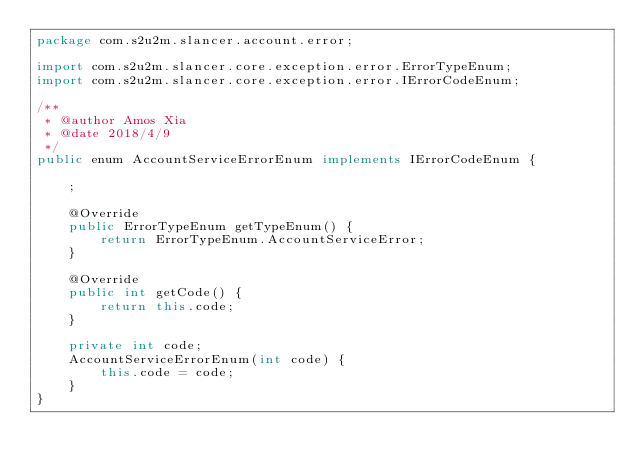Convert code to text. <code><loc_0><loc_0><loc_500><loc_500><_Java_>package com.s2u2m.slancer.account.error;

import com.s2u2m.slancer.core.exception.error.ErrorTypeEnum;
import com.s2u2m.slancer.core.exception.error.IErrorCodeEnum;

/**
 * @author Amos Xia
 * @date 2018/4/9
 */
public enum AccountServiceErrorEnum implements IErrorCodeEnum {

    ;

    @Override
    public ErrorTypeEnum getTypeEnum() {
        return ErrorTypeEnum.AccountServiceError;
    }

    @Override
    public int getCode() {
        return this.code;
    }

    private int code;
    AccountServiceErrorEnum(int code) {
        this.code = code;
    }
}
</code> 